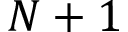Convert formula to latex. <formula><loc_0><loc_0><loc_500><loc_500>N + 1</formula> 